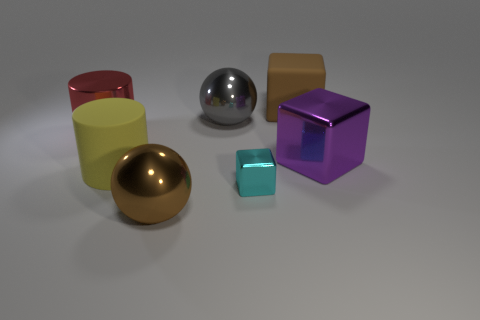Subtract all big brown blocks. How many blocks are left? 2 Add 1 gray shiny balls. How many objects exist? 8 Subtract 1 cubes. How many cubes are left? 2 Subtract all cyan blocks. How many blocks are left? 2 Subtract all small purple cylinders. Subtract all big purple metallic objects. How many objects are left? 6 Add 1 small objects. How many small objects are left? 2 Add 7 large purple shiny blocks. How many large purple shiny blocks exist? 8 Subtract 1 red cylinders. How many objects are left? 6 Subtract all spheres. How many objects are left? 5 Subtract all purple cubes. Subtract all brown cylinders. How many cubes are left? 2 